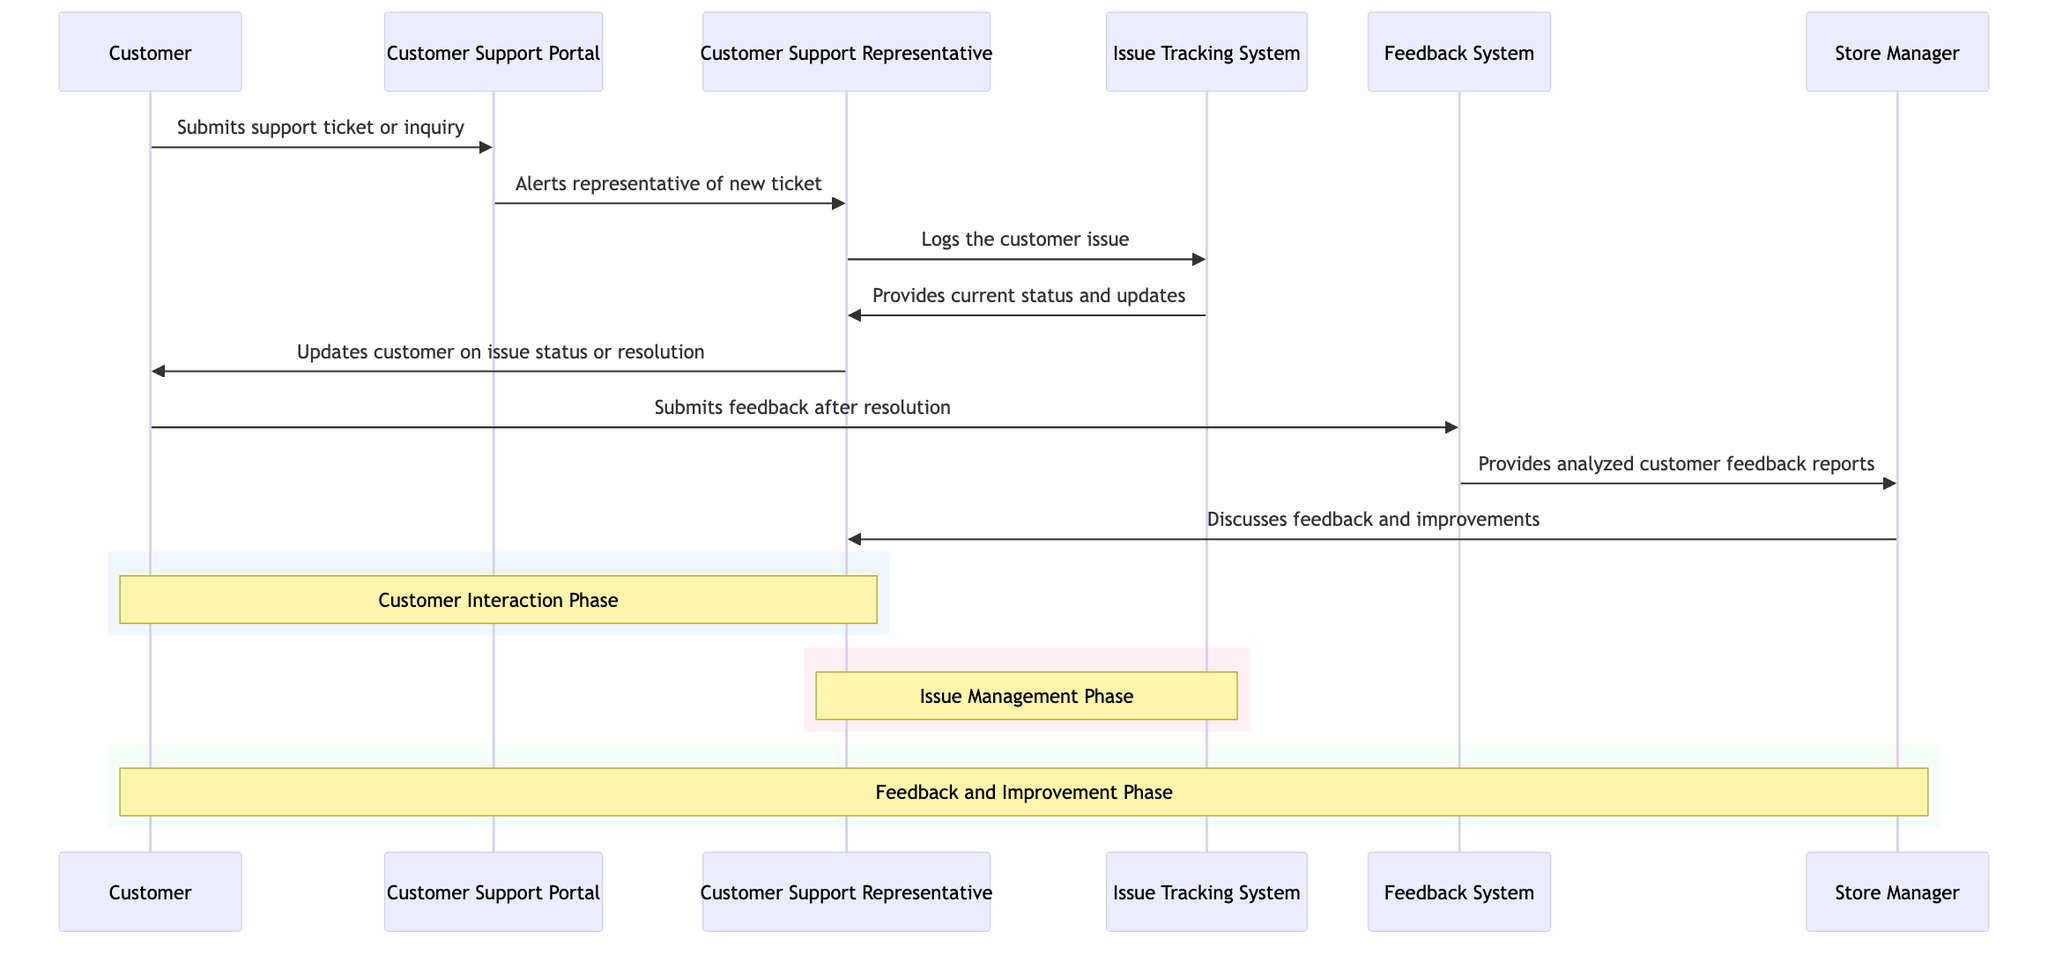What is the first action initiated by the Customer? The Customer submits a support ticket or inquiry, which is the first action depicted in the diagram. It shows the beginning of the interaction between the Customer and the Customer Support Portal.
Answer: Submits support ticket or inquiry How many actors are involved in the sequence? There are four actors involved: Customer, Customer Support Representative, Store Manager, and Feedback System. Each actor has a distinct role in the customer support process.
Answer: Four Which system is used by the Customer Support Representative to log issues? The Customer Support Representative uses the Issue Tracking System to log the customer issue, as indicated by the message from the CSR to the ITS.
Answer: Issue Tracking System What type of feedback does the Store Manager receive from the Feedback System? The Store Manager receives analyzed customer feedback reports, which are generated by the Feedback System and provided to the Store Manager.
Answer: Analyzed customer feedback reports What phase follows after the Customer submits feedback? The Feedback and Improvement Phase follows after the Customer submits feedback, as shown in the diagram where it connects to the Store Manager's actions.
Answer: Feedback and Improvement Phase Who discusses feedback and improvements with the Customer Support Representative? The Store Manager discusses feedback and improvements with the Customer Support Representative, as this interaction is depicted in the sequence following feedback analysis.
Answer: Store Manager How does the Customer get updates on the issue status? The Customer receives updates on the issue status or resolution from the Customer Support Representative, who communicates through email or call. This step is clearly defined in the flow of the diagram.
Answer: Updates customer What alerts the Customer Support Representative to a new ticket? The Customer Support Portal alerts the Customer Support Representative of a new ticket, enabling the representative to take action on it.
Answer: Alerts representative of new ticket What role does the Feedback System play after the Customer's issue is resolved? The Feedback System collects feedback from the Customer after the issue is resolved and provides analyzed reports to the Store Manager to inform improvements.
Answer: Provides analyzed feedback reports In which phase is the Customer interaction noted? The Customer Interaction Phase is noted specifically in the rectangle in the diagram, indicating the initial part where the Customer interacts with the Customer Support Portal.
Answer: Customer Interaction Phase 